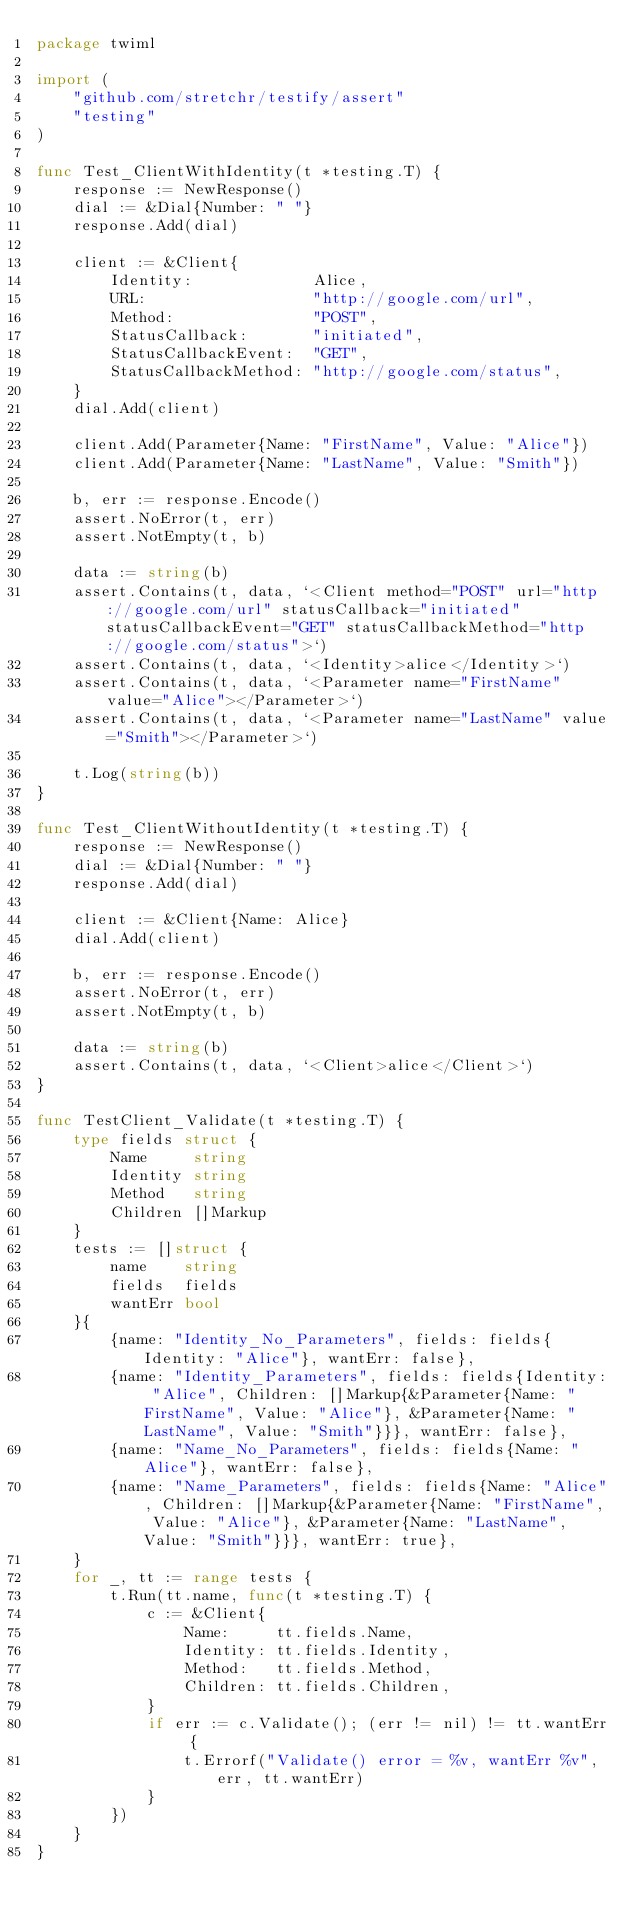<code> <loc_0><loc_0><loc_500><loc_500><_Go_>package twiml

import (
	"github.com/stretchr/testify/assert"
	"testing"
)

func Test_ClientWithIdentity(t *testing.T) {
	response := NewResponse()
	dial := &Dial{Number: " "}
	response.Add(dial)

	client := &Client{
		Identity:             Alice,
		URL:                  "http://google.com/url",
		Method:               "POST",
		StatusCallback:       "initiated",
		StatusCallbackEvent:  "GET",
		StatusCallbackMethod: "http://google.com/status",
	}
	dial.Add(client)

	client.Add(Parameter{Name: "FirstName", Value: "Alice"})
	client.Add(Parameter{Name: "LastName", Value: "Smith"})

	b, err := response.Encode()
	assert.NoError(t, err)
	assert.NotEmpty(t, b)

	data := string(b)
	assert.Contains(t, data, `<Client method="POST" url="http://google.com/url" statusCallback="initiated" statusCallbackEvent="GET" statusCallbackMethod="http://google.com/status">`)
	assert.Contains(t, data, `<Identity>alice</Identity>`)
	assert.Contains(t, data, `<Parameter name="FirstName" value="Alice"></Parameter>`)
	assert.Contains(t, data, `<Parameter name="LastName" value="Smith"></Parameter>`)

	t.Log(string(b))
}

func Test_ClientWithoutIdentity(t *testing.T) {
	response := NewResponse()
	dial := &Dial{Number: " "}
	response.Add(dial)

	client := &Client{Name: Alice}
	dial.Add(client)

	b, err := response.Encode()
	assert.NoError(t, err)
	assert.NotEmpty(t, b)

	data := string(b)
	assert.Contains(t, data, `<Client>alice</Client>`)
}

func TestClient_Validate(t *testing.T) {
	type fields struct {
		Name     string
		Identity string
		Method   string
		Children []Markup
	}
	tests := []struct {
		name    string
		fields  fields
		wantErr bool
	}{
		{name: "Identity_No_Parameters", fields: fields{Identity: "Alice"}, wantErr: false},
		{name: "Identity_Parameters", fields: fields{Identity: "Alice", Children: []Markup{&Parameter{Name: "FirstName", Value: "Alice"}, &Parameter{Name: "LastName", Value: "Smith"}}}, wantErr: false},
		{name: "Name_No_Parameters", fields: fields{Name: "Alice"}, wantErr: false},
		{name: "Name_Parameters", fields: fields{Name: "Alice", Children: []Markup{&Parameter{Name: "FirstName", Value: "Alice"}, &Parameter{Name: "LastName", Value: "Smith"}}}, wantErr: true},
	}
	for _, tt := range tests {
		t.Run(tt.name, func(t *testing.T) {
			c := &Client{
				Name:     tt.fields.Name,
				Identity: tt.fields.Identity,
				Method:   tt.fields.Method,
				Children: tt.fields.Children,
			}
			if err := c.Validate(); (err != nil) != tt.wantErr {
				t.Errorf("Validate() error = %v, wantErr %v", err, tt.wantErr)
			}
		})
	}
}
</code> 